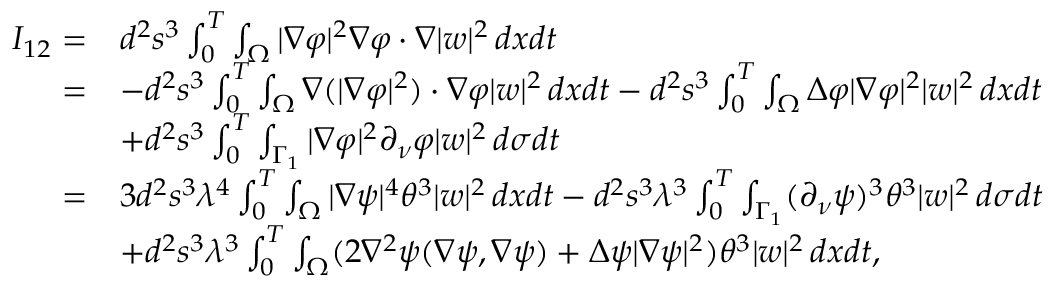<formula> <loc_0><loc_0><loc_500><loc_500>\begin{array} { r l } { I _ { 1 2 } = } & { d ^ { 2 } s ^ { 3 } \int _ { 0 } ^ { T } \int _ { \Omega } | \nabla \varphi | ^ { 2 } \nabla \varphi \cdot \nabla | w | ^ { 2 } \, d x d t } \\ { = } & { - d ^ { 2 } s ^ { 3 } \int _ { 0 } ^ { T } \int _ { \Omega } \nabla ( | \nabla \varphi | ^ { 2 } ) \cdot \nabla \varphi | w | ^ { 2 } \, d x d t - d ^ { 2 } s ^ { 3 } \int _ { 0 } ^ { T } \int _ { \Omega } \Delta \varphi | \nabla \varphi | ^ { 2 } | w | ^ { 2 } \, d x d t } \\ & { + d ^ { 2 } s ^ { 3 } \int _ { 0 } ^ { T } \int _ { \Gamma _ { 1 } } | \nabla \varphi | ^ { 2 } \partial _ { \nu } \varphi | w | ^ { 2 } \, d \sigma d t } \\ { = } & { 3 d ^ { 2 } s ^ { 3 } \lambda ^ { 4 } \int _ { 0 } ^ { T } \int _ { \Omega } | \nabla \psi | ^ { 4 } \theta ^ { 3 } | w | ^ { 2 } \, d x d t - d ^ { 2 } s ^ { 3 } \lambda ^ { 3 } \int _ { 0 } ^ { T } \int _ { \Gamma _ { 1 } } ( \partial _ { \nu } \psi ) ^ { 3 } \theta ^ { 3 } | w | ^ { 2 } \, d \sigma d t } \\ & { + d ^ { 2 } s ^ { 3 } \lambda ^ { 3 } \int _ { 0 } ^ { T } \int _ { \Omega } ( 2 \nabla ^ { 2 } \psi ( \nabla \psi , \nabla \psi ) + \Delta \psi | \nabla \psi | ^ { 2 } ) \theta ^ { 3 } | w | ^ { 2 } \, d x d t , } \end{array}</formula> 